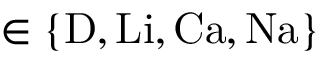Convert formula to latex. <formula><loc_0><loc_0><loc_500><loc_500>\in \{ D , L i , C a , N a \}</formula> 